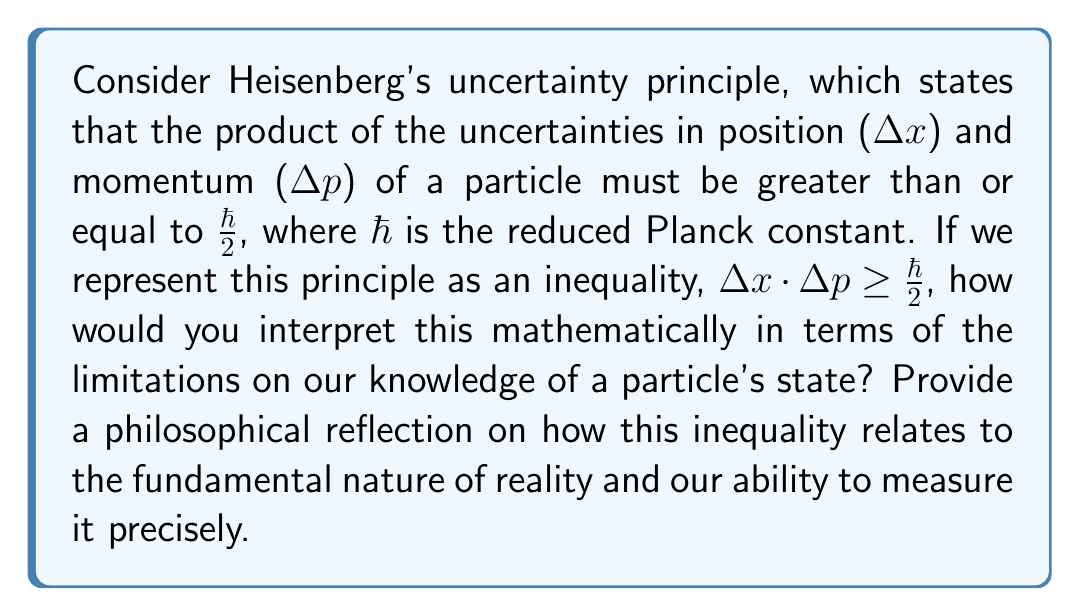Solve this math problem. Let's approach this step-by-step:

1) The mathematical representation of Heisenberg's uncertainty principle is:

   $$\Delta x \cdot \Delta p \geq \frac{\hbar}{2}$$

2) This inequality tells us that the product of the uncertainties in position and momentum has a fundamental lower bound.

3) Mathematically, we can interpret this as follows:
   - If $\Delta x$ decreases (i.e., we measure position more precisely), $\Delta p$ must increase to maintain the inequality.
   - Conversely, if $\Delta p$ decreases, $\Delta x$ must increase.

4) This leads to an inverse relationship between $\Delta x$ and $\Delta p$, which we can express as:

   $$\Delta x \geq \frac{\hbar}{2\Delta p}$$ and $$\Delta p \geq \frac{\hbar}{2\Delta x}$$

5) These inequalities show that as one uncertainty approaches zero, the other must approach infinity to satisfy the original inequality.

6) Philosophically, this implies that:
   - Perfect knowledge of both position and momentum simultaneously is impossible.
   - There's a fundamental limit to the precision with which we can know the state of a particle.
   - The act of measurement itself influences the system being measured.

7) This principle challenges classical determinism and suggests that the universe, at its most fundamental level, has an inherent uncertainty or "fuzziness."

8) The inequality represents not just a limitation of our measuring instruments, but a fundamental property of nature itself, suggesting that reality at the quantum level is probabilistic rather than deterministic.

9) This mathematical constraint on our knowledge raises profound questions about the nature of reality, free will, and the limits of human understanding.
Answer: The inequality $\Delta x \cdot \Delta p \geq \frac{\hbar}{2}$ mathematically expresses a fundamental limit on precise simultaneous knowledge of a particle's position and momentum, implying an inherent uncertainty in nature at the quantum level. 